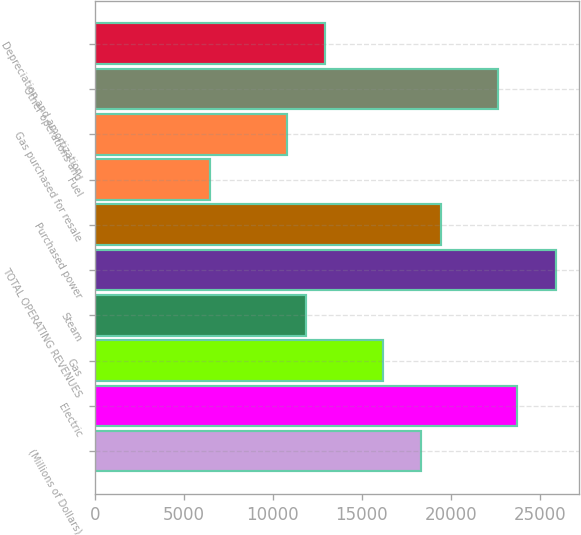Convert chart. <chart><loc_0><loc_0><loc_500><loc_500><bar_chart><fcel>(Millions of Dollars)<fcel>Electric<fcel>Gas<fcel>Steam<fcel>TOTAL OPERATING REVENUES<fcel>Purchased power<fcel>Fuel<fcel>Gas purchased for resale<fcel>Other operations and<fcel>Depreciation and amortization<nl><fcel>18335.5<fcel>23728<fcel>16178.5<fcel>11864.5<fcel>25885<fcel>19414<fcel>6472<fcel>10786<fcel>22649.5<fcel>12943<nl></chart> 